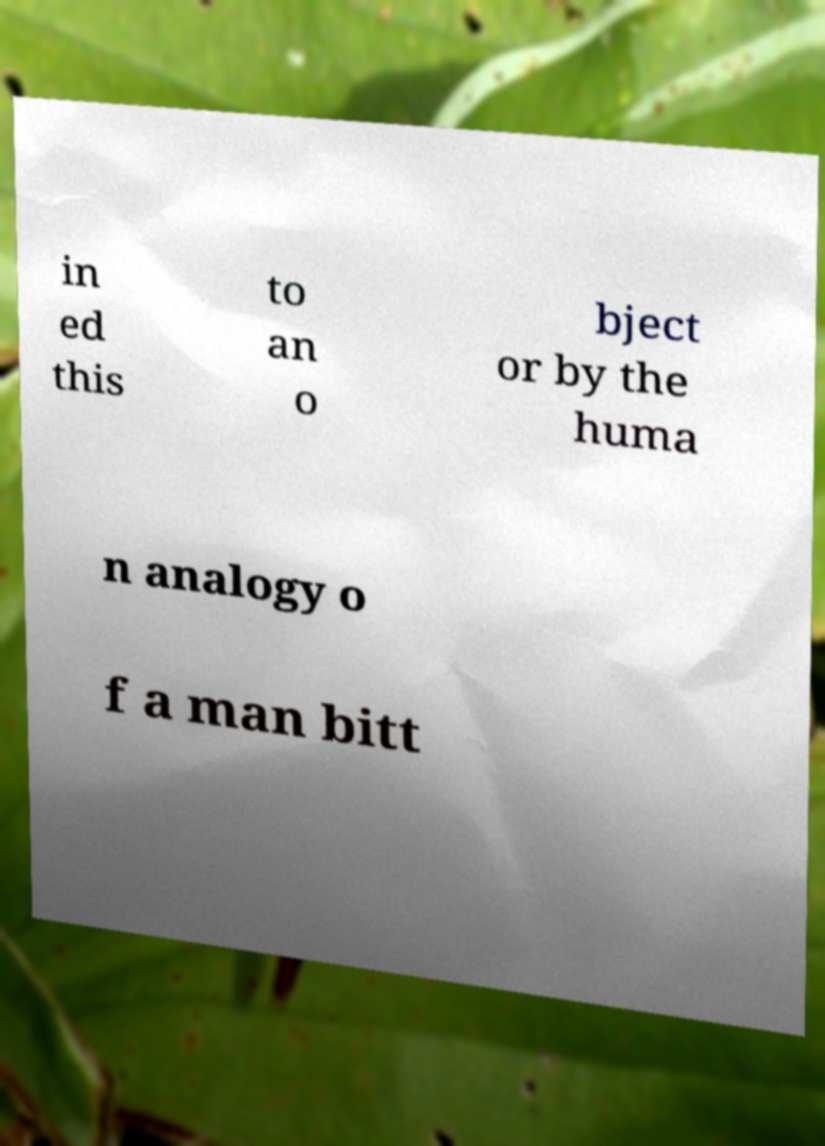For documentation purposes, I need the text within this image transcribed. Could you provide that? in ed this to an o bject or by the huma n analogy o f a man bitt 